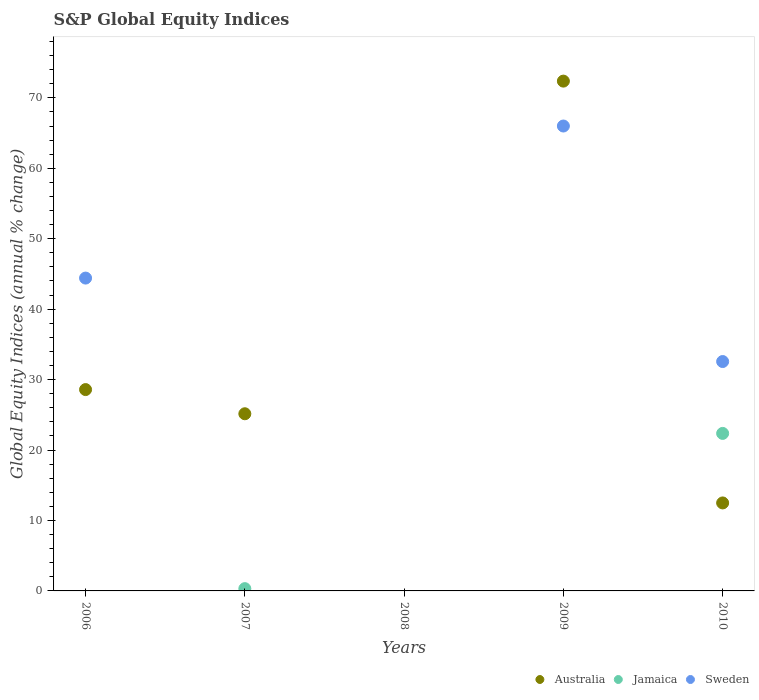What is the global equity indices in Australia in 2010?
Offer a terse response. 12.49. Across all years, what is the maximum global equity indices in Australia?
Your response must be concise. 72.37. Across all years, what is the minimum global equity indices in Jamaica?
Provide a succinct answer. 0. In which year was the global equity indices in Australia maximum?
Give a very brief answer. 2009. What is the total global equity indices in Australia in the graph?
Provide a succinct answer. 138.6. What is the difference between the global equity indices in Australia in 2007 and that in 2009?
Make the answer very short. -47.22. What is the difference between the global equity indices in Sweden in 2006 and the global equity indices in Jamaica in 2009?
Provide a succinct answer. 44.41. What is the average global equity indices in Australia per year?
Provide a short and direct response. 27.72. In the year 2010, what is the difference between the global equity indices in Jamaica and global equity indices in Australia?
Your answer should be compact. 9.87. What is the difference between the highest and the second highest global equity indices in Australia?
Provide a succinct answer. 43.79. What is the difference between the highest and the lowest global equity indices in Australia?
Offer a very short reply. 72.37. Is the sum of the global equity indices in Australia in 2006 and 2009 greater than the maximum global equity indices in Sweden across all years?
Offer a very short reply. Yes. Does the global equity indices in Australia monotonically increase over the years?
Your answer should be very brief. No. Is the global equity indices in Australia strictly greater than the global equity indices in Jamaica over the years?
Provide a short and direct response. No. How many dotlines are there?
Offer a very short reply. 3. What is the difference between two consecutive major ticks on the Y-axis?
Give a very brief answer. 10. Are the values on the major ticks of Y-axis written in scientific E-notation?
Give a very brief answer. No. Does the graph contain grids?
Keep it short and to the point. No. Where does the legend appear in the graph?
Offer a very short reply. Bottom right. How many legend labels are there?
Keep it short and to the point. 3. What is the title of the graph?
Keep it short and to the point. S&P Global Equity Indices. What is the label or title of the X-axis?
Ensure brevity in your answer.  Years. What is the label or title of the Y-axis?
Offer a terse response. Global Equity Indices (annual % change). What is the Global Equity Indices (annual % change) in Australia in 2006?
Your answer should be compact. 28.58. What is the Global Equity Indices (annual % change) in Sweden in 2006?
Offer a very short reply. 44.41. What is the Global Equity Indices (annual % change) of Australia in 2007?
Make the answer very short. 25.15. What is the Global Equity Indices (annual % change) of Jamaica in 2007?
Your response must be concise. 0.32. What is the Global Equity Indices (annual % change) of Australia in 2008?
Keep it short and to the point. 0. What is the Global Equity Indices (annual % change) of Sweden in 2008?
Keep it short and to the point. 0. What is the Global Equity Indices (annual % change) of Australia in 2009?
Keep it short and to the point. 72.37. What is the Global Equity Indices (annual % change) of Sweden in 2009?
Make the answer very short. 66. What is the Global Equity Indices (annual % change) of Australia in 2010?
Provide a succinct answer. 12.49. What is the Global Equity Indices (annual % change) of Jamaica in 2010?
Offer a very short reply. 22.36. What is the Global Equity Indices (annual % change) in Sweden in 2010?
Your answer should be compact. 32.56. Across all years, what is the maximum Global Equity Indices (annual % change) of Australia?
Make the answer very short. 72.37. Across all years, what is the maximum Global Equity Indices (annual % change) of Jamaica?
Provide a succinct answer. 22.36. Across all years, what is the maximum Global Equity Indices (annual % change) in Sweden?
Provide a succinct answer. 66. Across all years, what is the minimum Global Equity Indices (annual % change) of Australia?
Your response must be concise. 0. Across all years, what is the minimum Global Equity Indices (annual % change) in Jamaica?
Your answer should be very brief. 0. Across all years, what is the minimum Global Equity Indices (annual % change) of Sweden?
Provide a succinct answer. 0. What is the total Global Equity Indices (annual % change) of Australia in the graph?
Offer a very short reply. 138.6. What is the total Global Equity Indices (annual % change) of Jamaica in the graph?
Ensure brevity in your answer.  22.68. What is the total Global Equity Indices (annual % change) in Sweden in the graph?
Keep it short and to the point. 142.98. What is the difference between the Global Equity Indices (annual % change) of Australia in 2006 and that in 2007?
Offer a terse response. 3.43. What is the difference between the Global Equity Indices (annual % change) of Australia in 2006 and that in 2009?
Make the answer very short. -43.79. What is the difference between the Global Equity Indices (annual % change) in Sweden in 2006 and that in 2009?
Ensure brevity in your answer.  -21.59. What is the difference between the Global Equity Indices (annual % change) in Australia in 2006 and that in 2010?
Offer a very short reply. 16.09. What is the difference between the Global Equity Indices (annual % change) in Sweden in 2006 and that in 2010?
Make the answer very short. 11.85. What is the difference between the Global Equity Indices (annual % change) of Australia in 2007 and that in 2009?
Ensure brevity in your answer.  -47.22. What is the difference between the Global Equity Indices (annual % change) of Australia in 2007 and that in 2010?
Make the answer very short. 12.66. What is the difference between the Global Equity Indices (annual % change) of Jamaica in 2007 and that in 2010?
Give a very brief answer. -22.04. What is the difference between the Global Equity Indices (annual % change) in Australia in 2009 and that in 2010?
Keep it short and to the point. 59.88. What is the difference between the Global Equity Indices (annual % change) of Sweden in 2009 and that in 2010?
Ensure brevity in your answer.  33.44. What is the difference between the Global Equity Indices (annual % change) of Australia in 2006 and the Global Equity Indices (annual % change) of Jamaica in 2007?
Give a very brief answer. 28.26. What is the difference between the Global Equity Indices (annual % change) of Australia in 2006 and the Global Equity Indices (annual % change) of Sweden in 2009?
Keep it short and to the point. -37.42. What is the difference between the Global Equity Indices (annual % change) of Australia in 2006 and the Global Equity Indices (annual % change) of Jamaica in 2010?
Ensure brevity in your answer.  6.22. What is the difference between the Global Equity Indices (annual % change) of Australia in 2006 and the Global Equity Indices (annual % change) of Sweden in 2010?
Ensure brevity in your answer.  -3.98. What is the difference between the Global Equity Indices (annual % change) in Australia in 2007 and the Global Equity Indices (annual % change) in Sweden in 2009?
Keep it short and to the point. -40.85. What is the difference between the Global Equity Indices (annual % change) in Jamaica in 2007 and the Global Equity Indices (annual % change) in Sweden in 2009?
Keep it short and to the point. -65.68. What is the difference between the Global Equity Indices (annual % change) of Australia in 2007 and the Global Equity Indices (annual % change) of Jamaica in 2010?
Make the answer very short. 2.79. What is the difference between the Global Equity Indices (annual % change) in Australia in 2007 and the Global Equity Indices (annual % change) in Sweden in 2010?
Give a very brief answer. -7.41. What is the difference between the Global Equity Indices (annual % change) in Jamaica in 2007 and the Global Equity Indices (annual % change) in Sweden in 2010?
Make the answer very short. -32.24. What is the difference between the Global Equity Indices (annual % change) of Australia in 2009 and the Global Equity Indices (annual % change) of Jamaica in 2010?
Provide a short and direct response. 50.01. What is the difference between the Global Equity Indices (annual % change) in Australia in 2009 and the Global Equity Indices (annual % change) in Sweden in 2010?
Your answer should be compact. 39.81. What is the average Global Equity Indices (annual % change) of Australia per year?
Give a very brief answer. 27.72. What is the average Global Equity Indices (annual % change) in Jamaica per year?
Ensure brevity in your answer.  4.54. What is the average Global Equity Indices (annual % change) in Sweden per year?
Offer a terse response. 28.6. In the year 2006, what is the difference between the Global Equity Indices (annual % change) of Australia and Global Equity Indices (annual % change) of Sweden?
Provide a short and direct response. -15.83. In the year 2007, what is the difference between the Global Equity Indices (annual % change) of Australia and Global Equity Indices (annual % change) of Jamaica?
Provide a succinct answer. 24.83. In the year 2009, what is the difference between the Global Equity Indices (annual % change) in Australia and Global Equity Indices (annual % change) in Sweden?
Your answer should be very brief. 6.37. In the year 2010, what is the difference between the Global Equity Indices (annual % change) in Australia and Global Equity Indices (annual % change) in Jamaica?
Your answer should be compact. -9.87. In the year 2010, what is the difference between the Global Equity Indices (annual % change) in Australia and Global Equity Indices (annual % change) in Sweden?
Provide a short and direct response. -20.07. In the year 2010, what is the difference between the Global Equity Indices (annual % change) in Jamaica and Global Equity Indices (annual % change) in Sweden?
Your answer should be very brief. -10.2. What is the ratio of the Global Equity Indices (annual % change) of Australia in 2006 to that in 2007?
Provide a succinct answer. 1.14. What is the ratio of the Global Equity Indices (annual % change) of Australia in 2006 to that in 2009?
Offer a very short reply. 0.39. What is the ratio of the Global Equity Indices (annual % change) in Sweden in 2006 to that in 2009?
Offer a very short reply. 0.67. What is the ratio of the Global Equity Indices (annual % change) in Australia in 2006 to that in 2010?
Provide a short and direct response. 2.29. What is the ratio of the Global Equity Indices (annual % change) of Sweden in 2006 to that in 2010?
Keep it short and to the point. 1.36. What is the ratio of the Global Equity Indices (annual % change) of Australia in 2007 to that in 2009?
Make the answer very short. 0.35. What is the ratio of the Global Equity Indices (annual % change) of Australia in 2007 to that in 2010?
Ensure brevity in your answer.  2.01. What is the ratio of the Global Equity Indices (annual % change) in Jamaica in 2007 to that in 2010?
Give a very brief answer. 0.01. What is the ratio of the Global Equity Indices (annual % change) of Australia in 2009 to that in 2010?
Make the answer very short. 5.79. What is the ratio of the Global Equity Indices (annual % change) in Sweden in 2009 to that in 2010?
Offer a terse response. 2.03. What is the difference between the highest and the second highest Global Equity Indices (annual % change) in Australia?
Offer a terse response. 43.79. What is the difference between the highest and the second highest Global Equity Indices (annual % change) in Sweden?
Ensure brevity in your answer.  21.59. What is the difference between the highest and the lowest Global Equity Indices (annual % change) in Australia?
Keep it short and to the point. 72.37. What is the difference between the highest and the lowest Global Equity Indices (annual % change) of Jamaica?
Your answer should be very brief. 22.36. What is the difference between the highest and the lowest Global Equity Indices (annual % change) of Sweden?
Your answer should be compact. 66. 